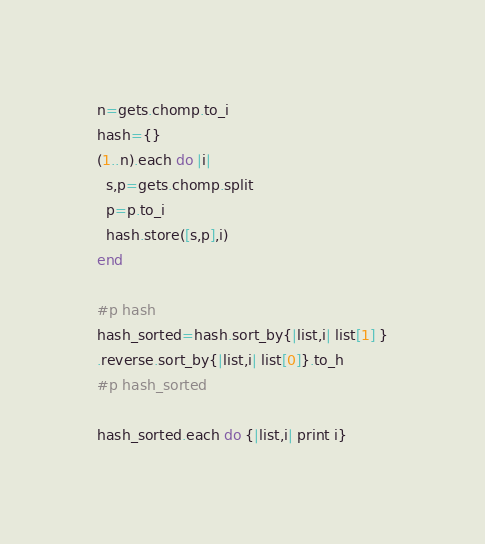Convert code to text. <code><loc_0><loc_0><loc_500><loc_500><_Ruby_>n=gets.chomp.to_i
hash={}
(1..n).each do |i|
  s,p=gets.chomp.split
  p=p.to_i
  hash.store([s,p],i)
end

#p hash
hash_sorted=hash.sort_by{|list,i| list[1] }
.reverse.sort_by{|list,i| list[0]}.to_h
#p hash_sorted

hash_sorted.each do {|list,i| print i}
</code> 